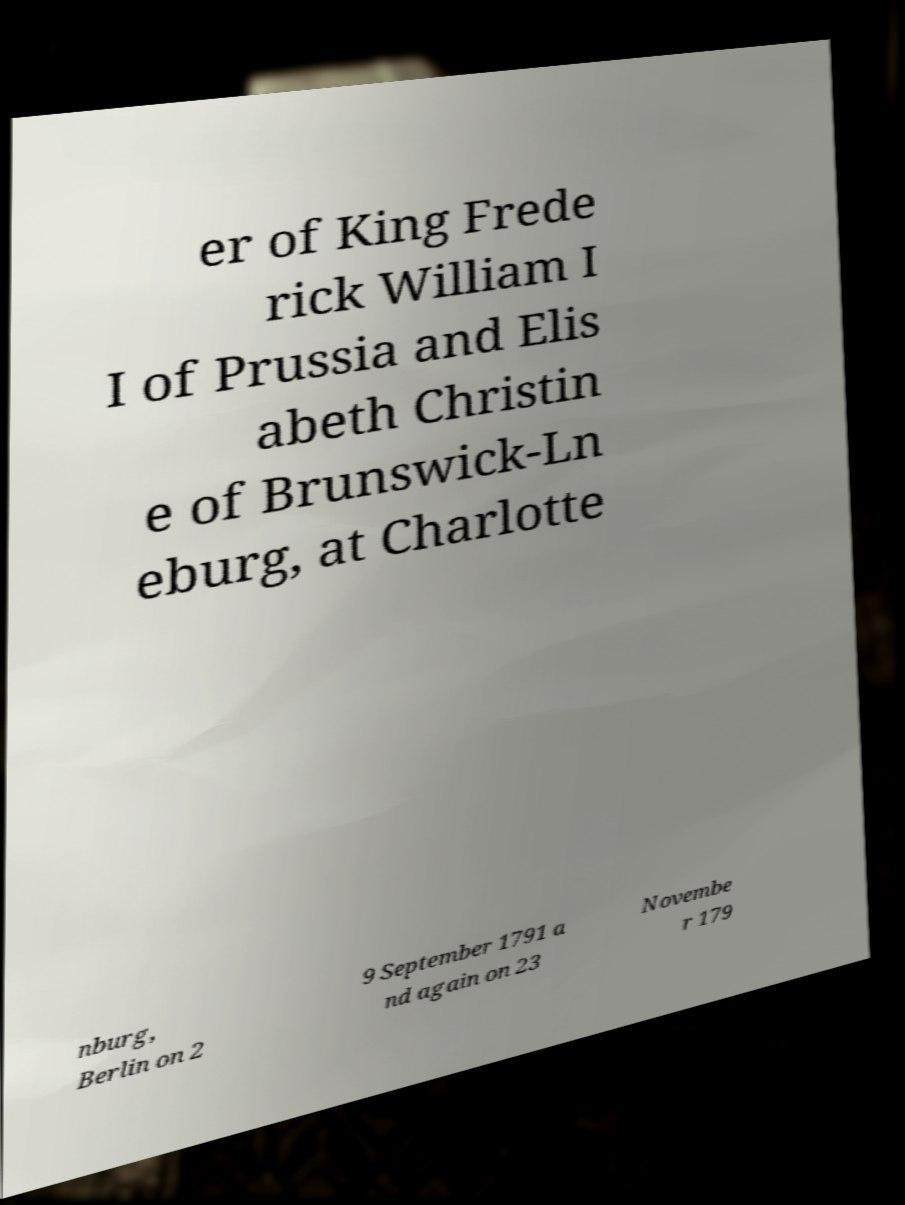Please read and relay the text visible in this image. What does it say? er of King Frede rick William I I of Prussia and Elis abeth Christin e of Brunswick-Ln eburg, at Charlotte nburg, Berlin on 2 9 September 1791 a nd again on 23 Novembe r 179 